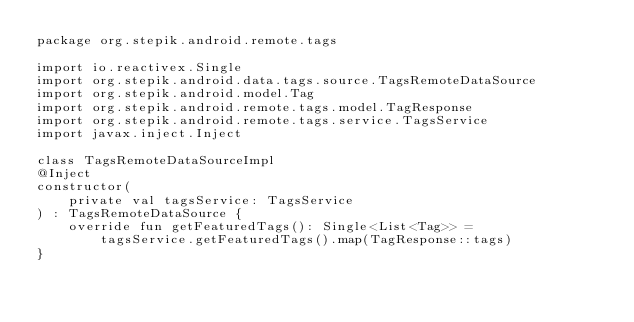Convert code to text. <code><loc_0><loc_0><loc_500><loc_500><_Kotlin_>package org.stepik.android.remote.tags

import io.reactivex.Single
import org.stepik.android.data.tags.source.TagsRemoteDataSource
import org.stepik.android.model.Tag
import org.stepik.android.remote.tags.model.TagResponse
import org.stepik.android.remote.tags.service.TagsService
import javax.inject.Inject

class TagsRemoteDataSourceImpl
@Inject
constructor(
    private val tagsService: TagsService
) : TagsRemoteDataSource {
    override fun getFeaturedTags(): Single<List<Tag>> =
        tagsService.getFeaturedTags().map(TagResponse::tags)
}</code> 